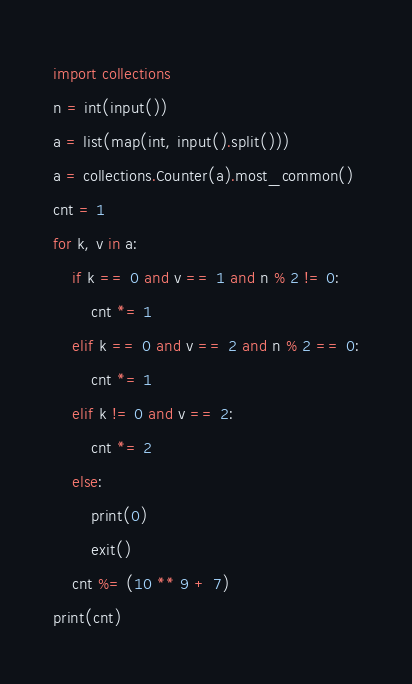Convert code to text. <code><loc_0><loc_0><loc_500><loc_500><_Python_>import collections
n = int(input())
a = list(map(int, input().split()))
a = collections.Counter(a).most_common()
cnt = 1
for k, v in a:
    if k == 0 and v == 1 and n % 2 != 0:
        cnt *= 1
    elif k == 0 and v == 2 and n % 2 == 0:
        cnt *= 1
    elif k != 0 and v == 2:
        cnt *= 2
    else:
        print(0)
        exit()
    cnt %= (10 ** 9 + 7)
print(cnt)
</code> 